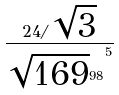Convert formula to latex. <formula><loc_0><loc_0><loc_500><loc_500>\frac { 2 4 / \sqrt { 3 } } { { \sqrt { 1 6 9 } ^ { 9 8 } } ^ { 5 } }</formula> 